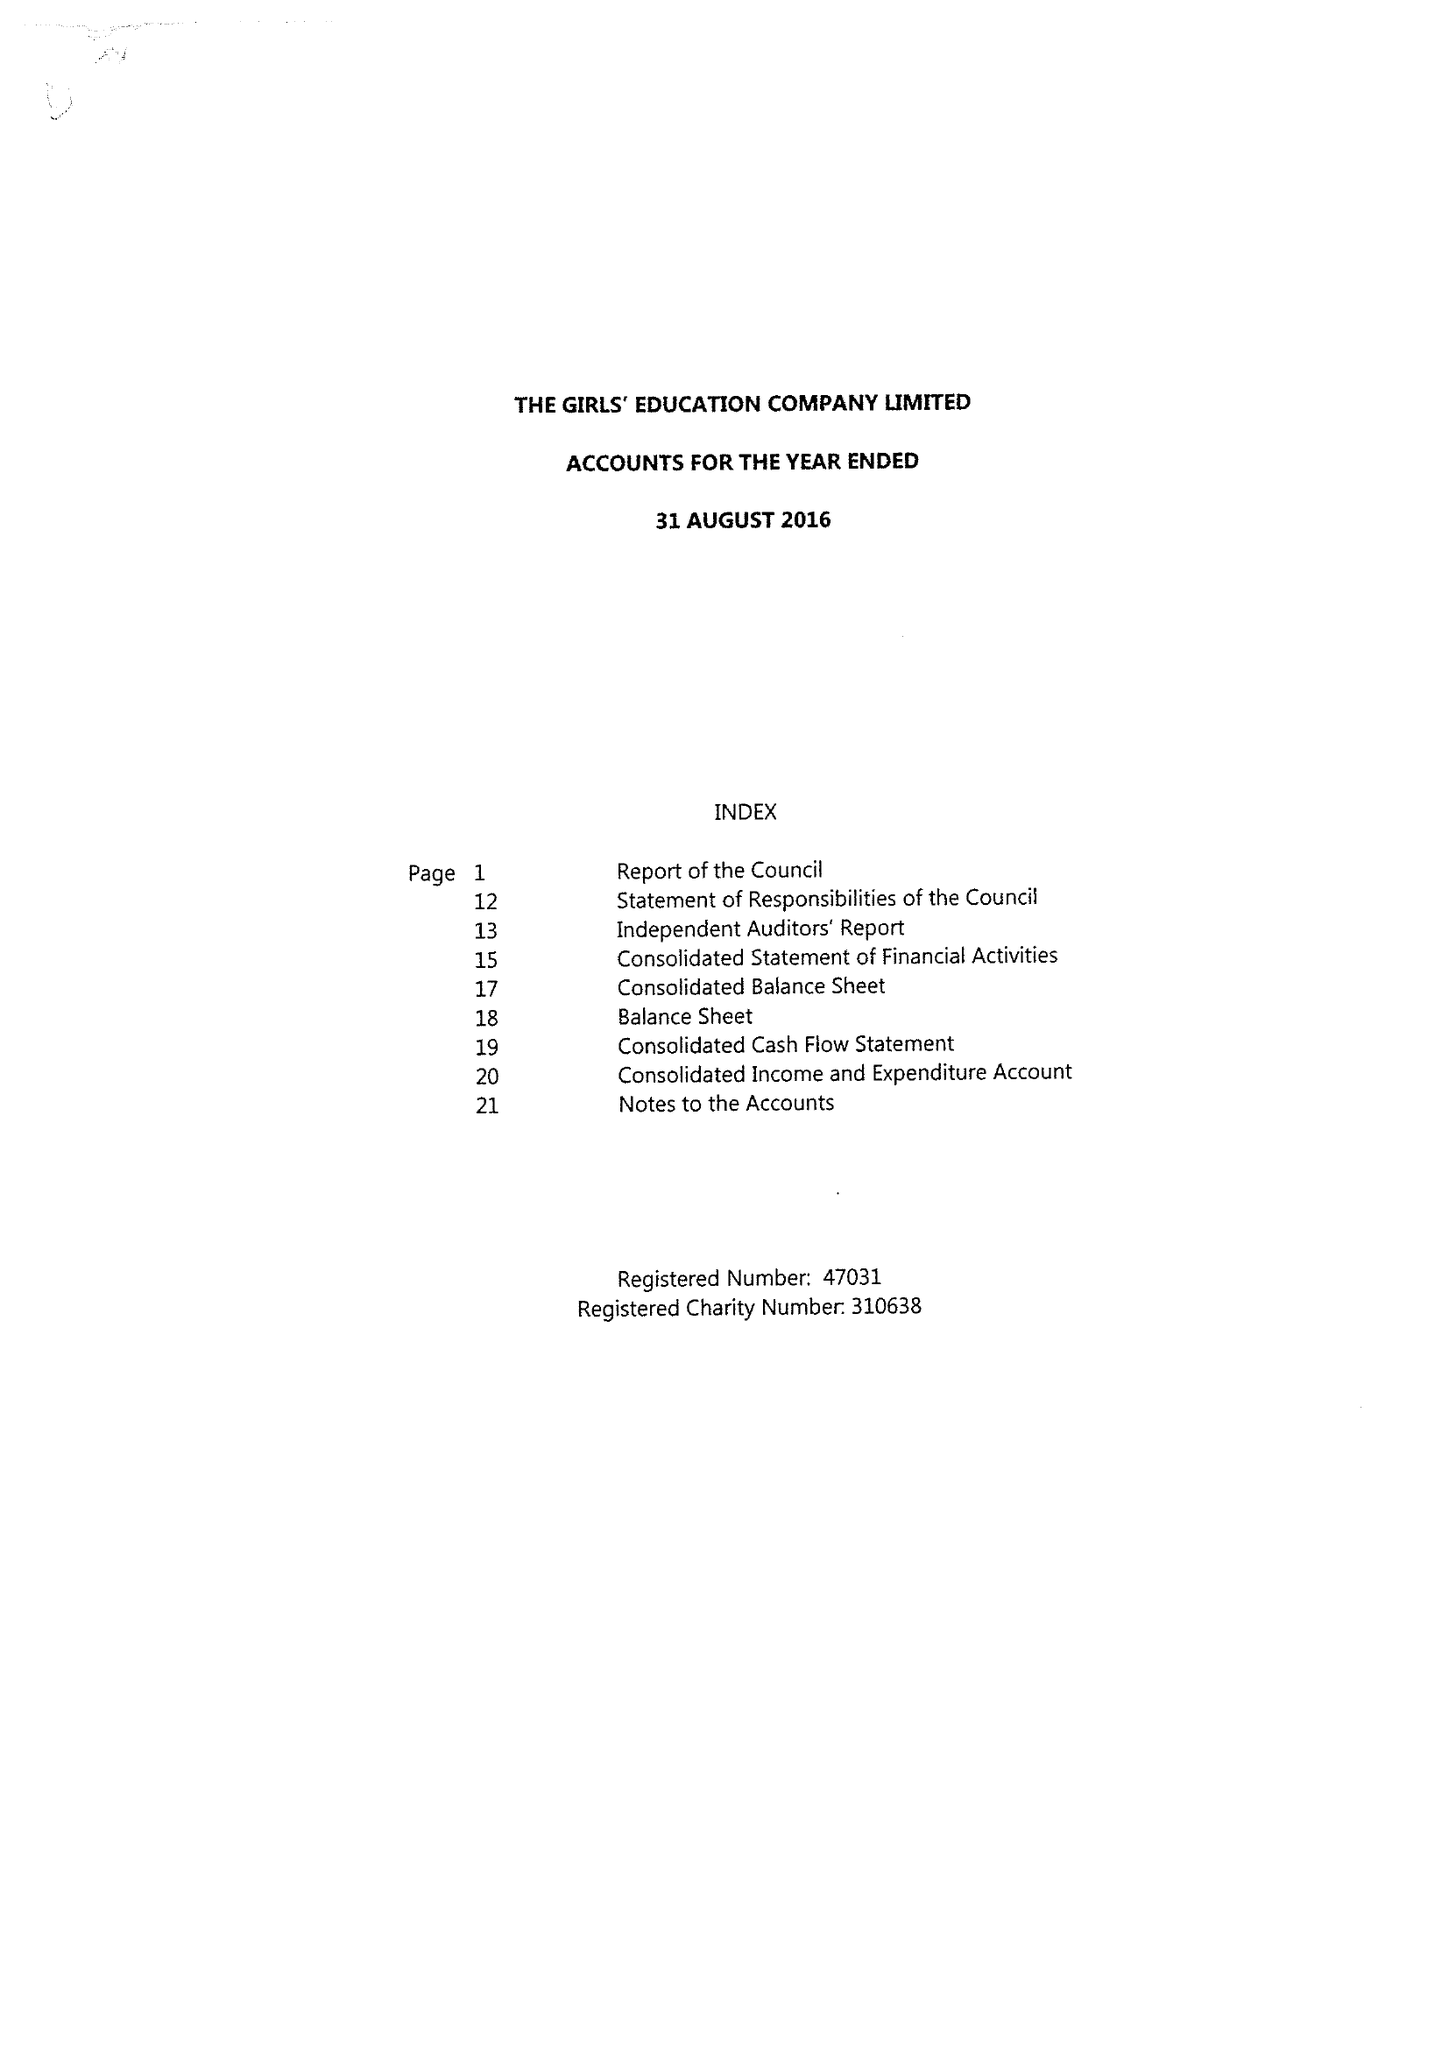What is the value for the charity_name?
Answer the question using a single word or phrase. Girls' Education Company Ltd. 